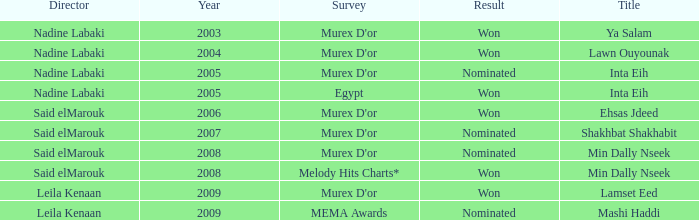What survey has the Ehsas Jdeed title? Murex D'or. 